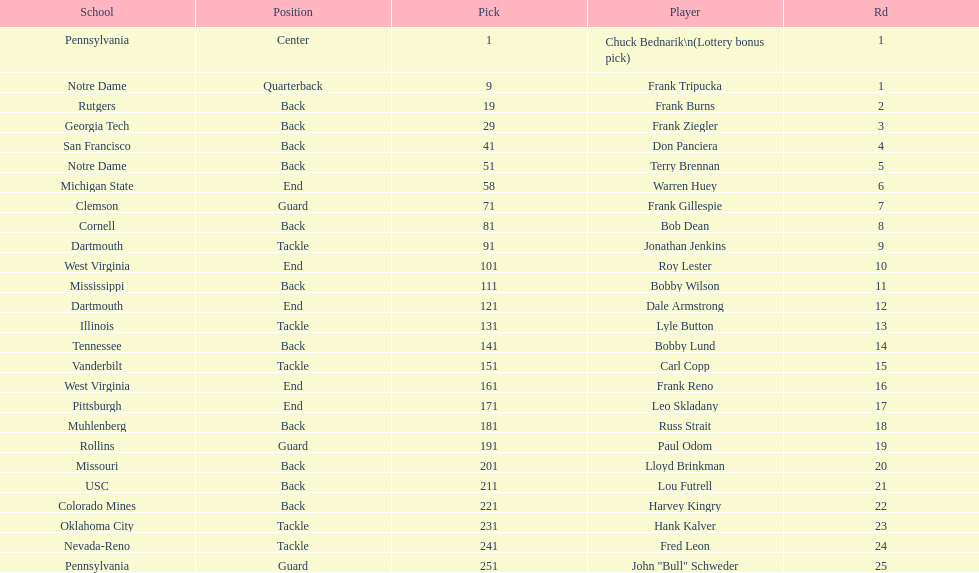Was chuck bednarik or frank tripucka the first draft pick? Chuck Bednarik. 